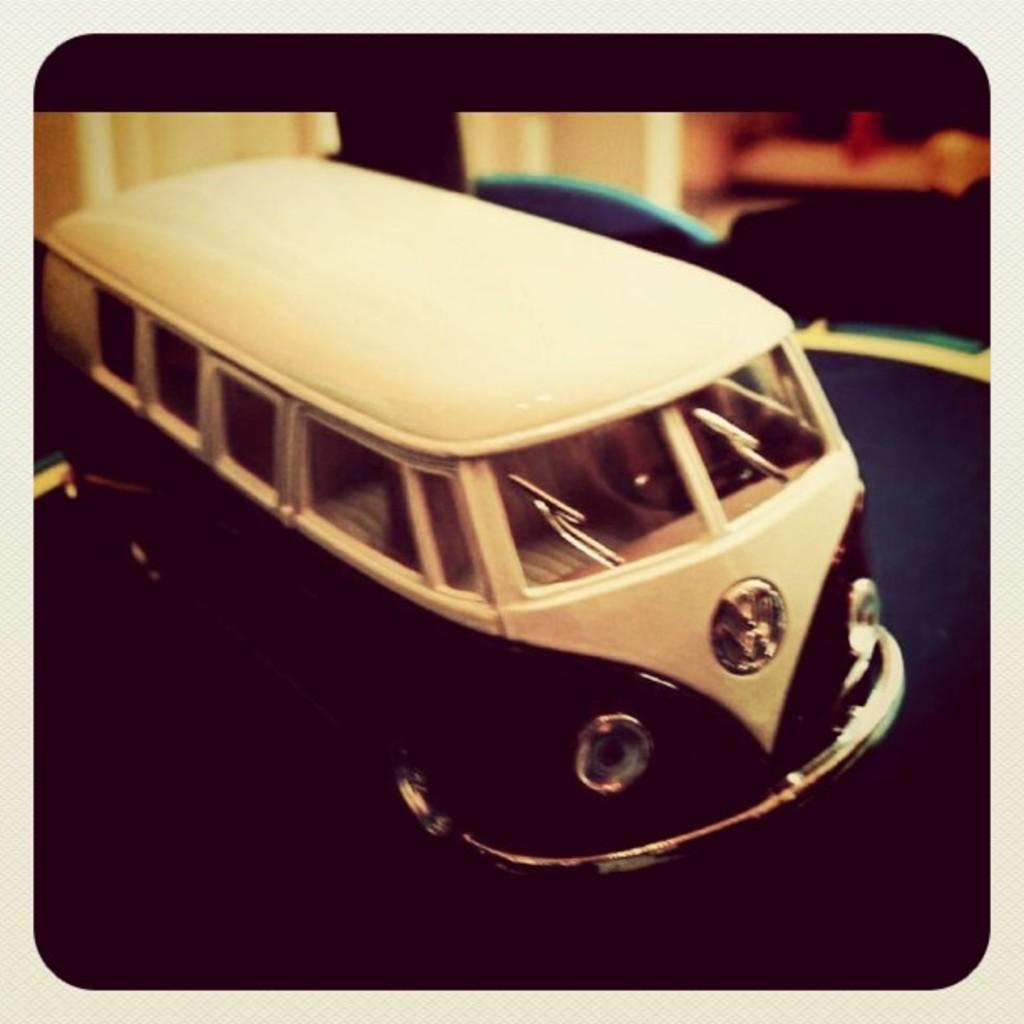What object can be seen in the image? There is a toy in the image. What type of surface is visible in the image? The ground is visible in the image. Can you describe the background of the image? The background of the image is blurred. Where is the throne located in the image? There is no throne present in the image. What type of pie is being served in the image? There is no pie present in the image. 